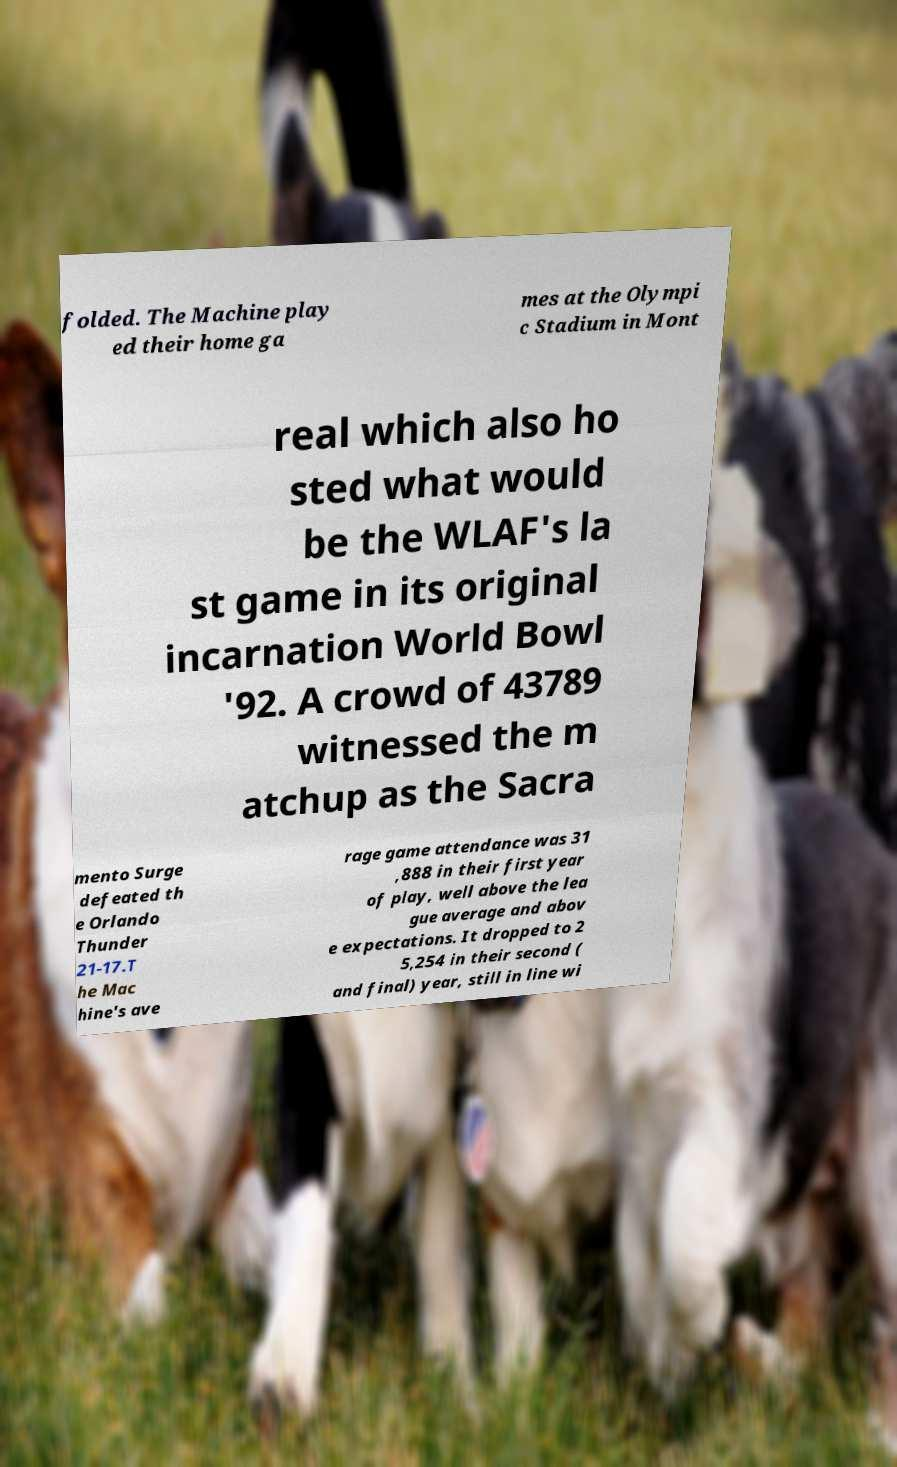Please identify and transcribe the text found in this image. folded. The Machine play ed their home ga mes at the Olympi c Stadium in Mont real which also ho sted what would be the WLAF's la st game in its original incarnation World Bowl '92. A crowd of 43789 witnessed the m atchup as the Sacra mento Surge defeated th e Orlando Thunder 21-17.T he Mac hine's ave rage game attendance was 31 ,888 in their first year of play, well above the lea gue average and abov e expectations. It dropped to 2 5,254 in their second ( and final) year, still in line wi 